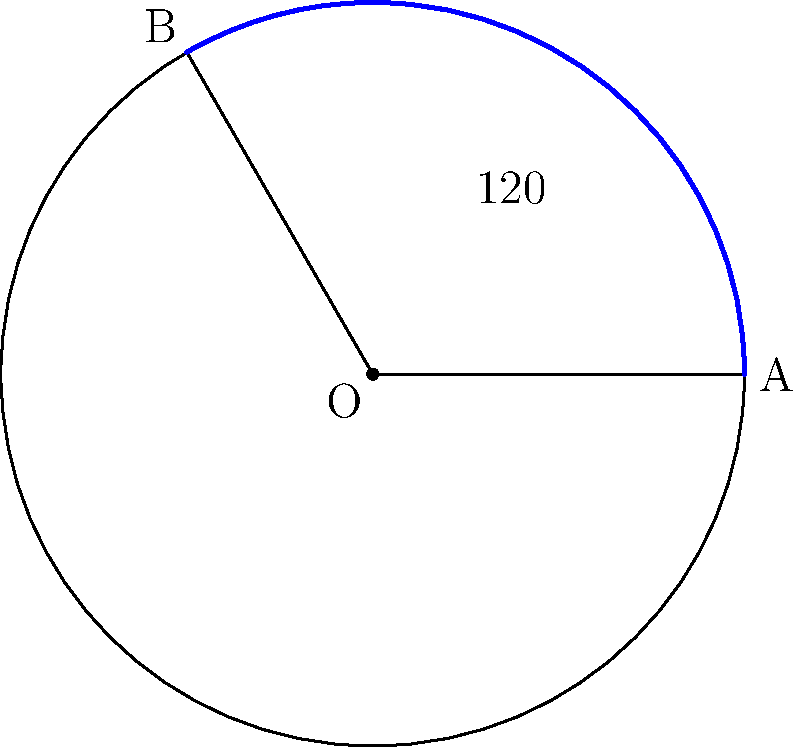You've designed a new circular irrigation system for a section of your organic farm. The system rotates around a central point, covering a 120° angle and has a radius of 30 meters. What is the area of land, in square meters, that this irrigation system covers? Round your answer to the nearest whole number. To solve this problem, we need to follow these steps:

1) The area covered by the irrigation system forms a sector of a circle. The formula for the area of a circular sector is:

   $$A = \frac{\theta}{360°} \pi r^2$$

   Where $\theta$ is the central angle in degrees, and $r$ is the radius.

2) We're given:
   - Angle $\theta = 120°$
   - Radius $r = 30$ meters

3) Let's substitute these values into our formula:

   $$A = \frac{120°}{360°} \pi (30\text{ m})^2$$

4) Simplify:
   $$A = \frac{1}{3} \pi (900\text{ m}^2)$$

5) Calculate:
   $$A = 300\pi \text{ m}^2$$

6) Use 3.14159 for $\pi$ and calculate:
   $$A = 300 * 3.14159 = 942.477 \text{ m}^2$$

7) Rounding to the nearest whole number:
   $$A \approx 942 \text{ m}^2$$
Answer: 942 m² 